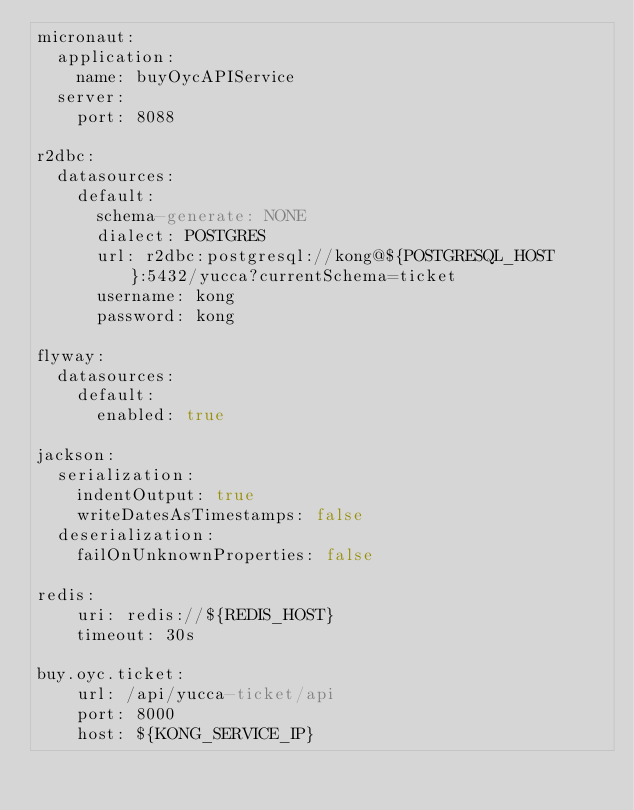<code> <loc_0><loc_0><loc_500><loc_500><_YAML_>micronaut:
  application:
    name: buyOycAPIService
  server:
    port: 8088

r2dbc:
  datasources:
    default:
      schema-generate: NONE
      dialect: POSTGRES
      url: r2dbc:postgresql://kong@${POSTGRESQL_HOST}:5432/yucca?currentSchema=ticket
      username: kong
      password: kong

flyway:
  datasources:
    default:
      enabled: true

jackson:
  serialization:
    indentOutput: true
    writeDatesAsTimestamps: false
  deserialization:
    failOnUnknownProperties: false

redis:
    uri: redis://${REDIS_HOST}
    timeout: 30s

buy.oyc.ticket:
    url: /api/yucca-ticket/api
    port: 8000
    host: ${KONG_SERVICE_IP}
</code> 